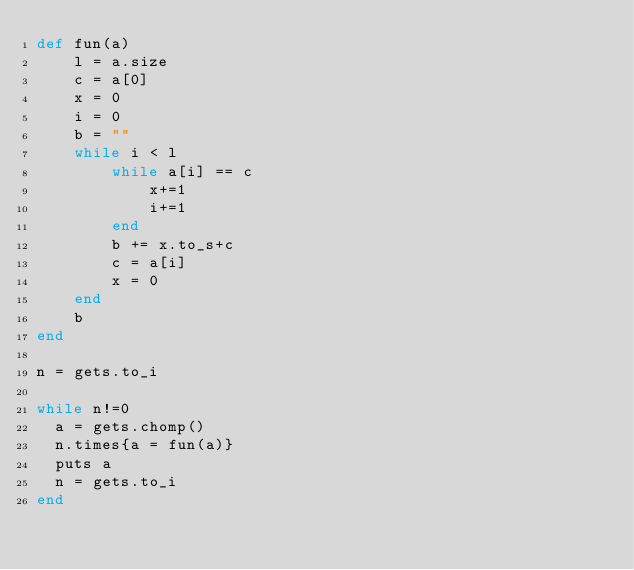<code> <loc_0><loc_0><loc_500><loc_500><_Ruby_>def fun(a)
    l = a.size
    c = a[0]
    x = 0
    i = 0
    b = ""
    while i < l
        while a[i] == c
            x+=1
            i+=1
        end
        b += x.to_s+c
        c = a[i]
        x = 0
    end
    b
end

n = gets.to_i

while n!=0
  a = gets.chomp()
  n.times{a = fun(a)}
  puts a
  n = gets.to_i
end</code> 